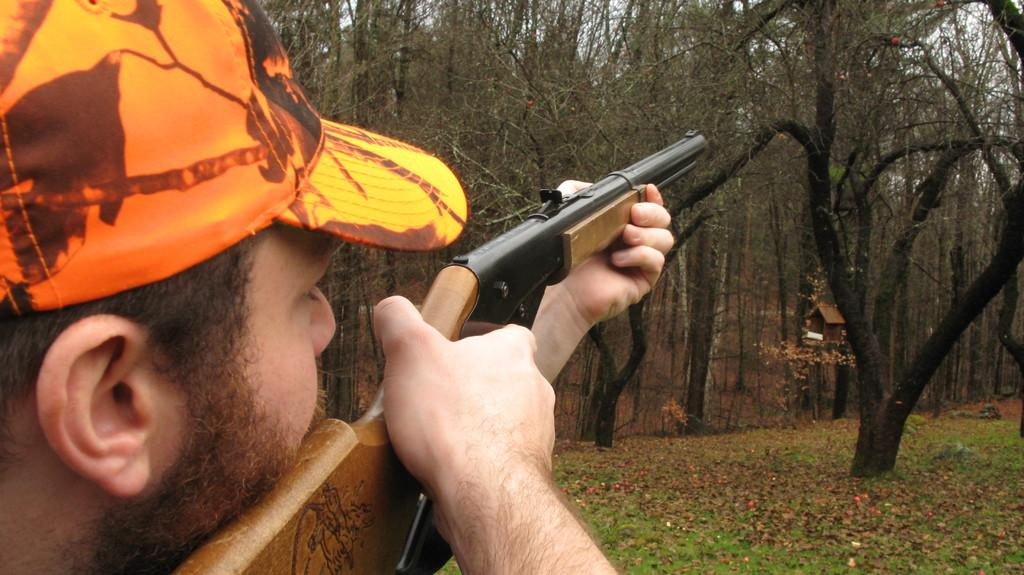What is the main subject of the image? There is a person in the image. What is the person holding in the image? The person is holding a gun. What type of headwear is the person wearing? The person is wearing a cap. What can be seen in the background of the image? There are trees and a small house in the background of the image. What type of flooring is visible in the image? There is grass on the floor in the image. How many kittens are playing with the meat in the image? There are no kittens or meat present in the image. What type of knowledge is the person gaining from the image? The image does not convey any specific knowledge, as it is a static representation of a person holding a gun and wearing a cap. 